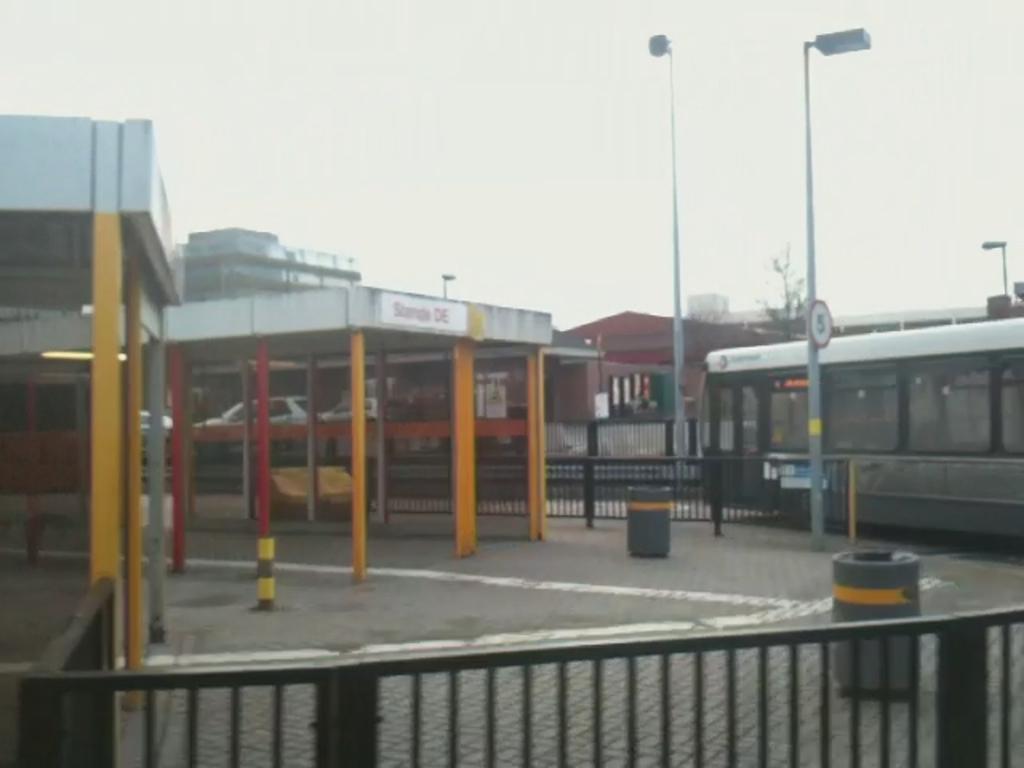Describe this image in one or two sentences. This picture is clicked outside the city. At the bottom of the picture, we see an iron railing. On the right side, we see a bus is moving on the road. Beside that, there are street lights. There are many buildings in the background. At the top of the picture, we see the sky. 